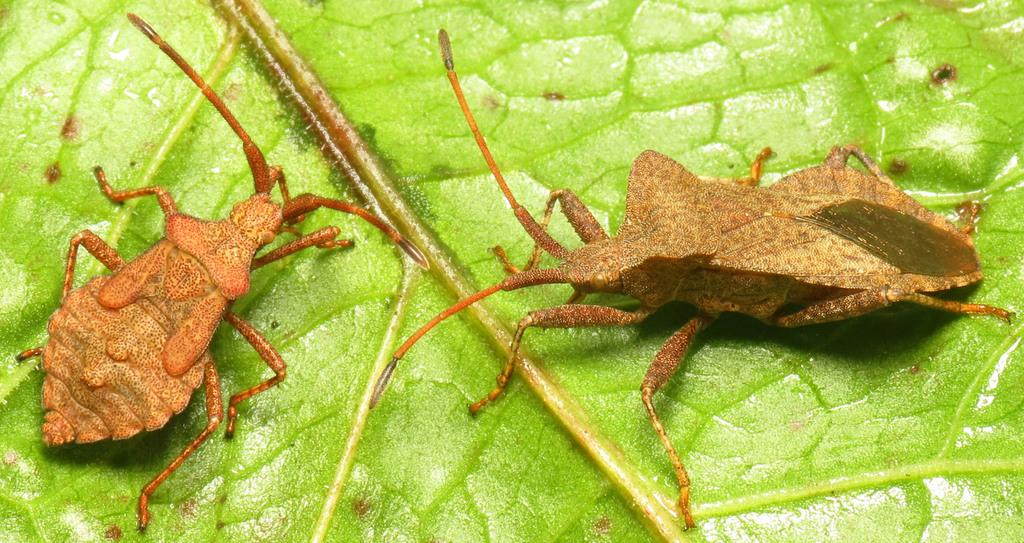How many insects are present in the image? There are two insects in the image. Where are the insects located? The insects are on a green leaf. What type of plane is visible in the image? There is no plane present in the image; it features two insects on a green leaf. What suggestion is being made in the image? There is no suggestion being made in the image; it simply shows two insects on a green leaf. 